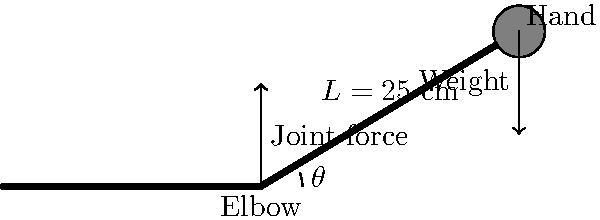A weightlifter is performing a bicep curl with a 20 kg dumbbell. The forearm length is 25 cm, and the angle between the forearm and the horizontal is 18°. Calculate the torque at the elbow joint, assuming the center of mass of the forearm is at its midpoint and has a mass of 1.5 kg. To calculate the joint torque at the elbow, we need to consider the forces acting on the forearm and their moments about the joint. Let's break this down step-by-step:

1) Convert the dumbbell mass to force:
   $F_{dumbbell} = 20 \text{ kg} \times 9.81 \text{ m/s}^2 = 196.2 \text{ N}$

2) Calculate the forearm's weight:
   $F_{forearm} = 1.5 \text{ kg} \times 9.81 \text{ m/s}^2 = 14.715 \text{ N}$

3) Calculate the moment arm for each force:
   - Dumbbell: $r_{dumbbell} = 0.25 \text{ m} \times \cos(18°) = 0.2377 \text{ m}$
   - Forearm: $r_{forearm} = 0.25 \text{ m} \times 0.5 \times \cos(18°) = 0.11885 \text{ m}$

4) Calculate the torque for each force:
   - Dumbbell torque: $\tau_{dumbbell} = 196.2 \text{ N} \times 0.2377 \text{ m} = 46.6257 \text{ Nm}$
   - Forearm torque: $\tau_{forearm} = 14.715 \text{ N} \times 0.11885 \text{ m} = 1.7489 \text{ Nm}$

5) Sum the torques to get the total joint torque:
   $\tau_{total} = 46.6257 \text{ Nm} + 1.7489 \text{ Nm} = 48.3746 \text{ Nm}$

Therefore, the torque at the elbow joint is approximately 48.37 Nm.
Answer: 48.37 Nm 